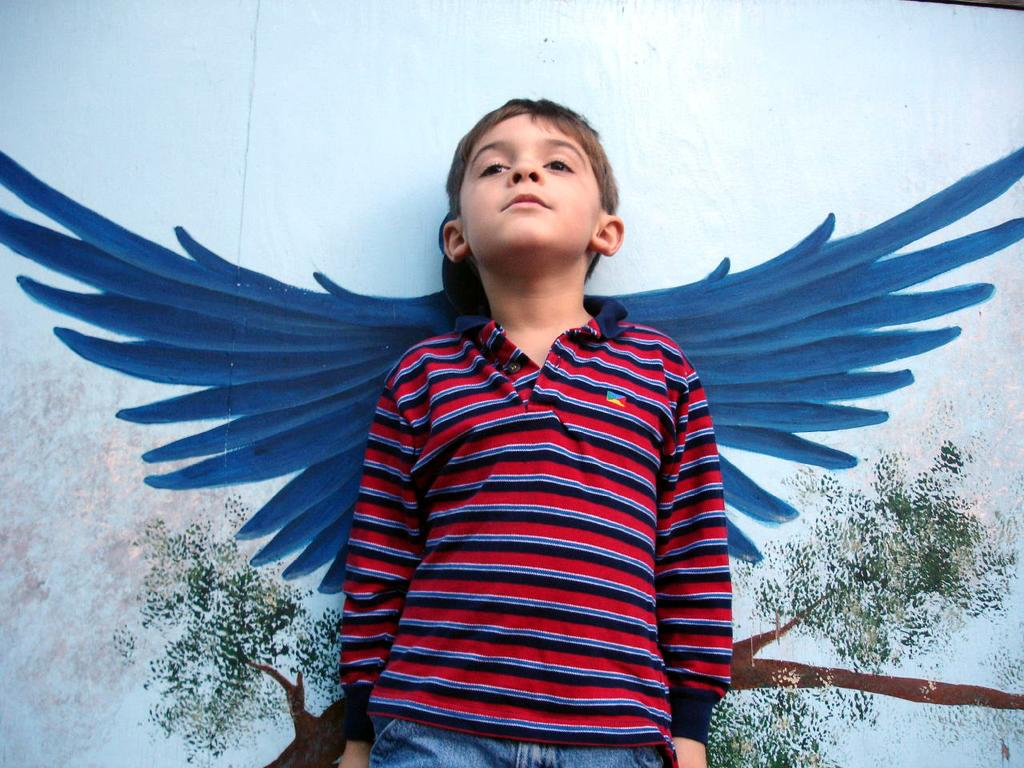What is the main subject of the image? There is a boy standing in the image. What can be seen in the background of the image? There is a painting of wings and a tree on the wall in the background of the image. How many rabbits are sitting on the boy's sweater in the image? There are no rabbits or sweaters present in the image. What stage of development is the boy in the image? The image does not provide information about the boy's developmental stage. 